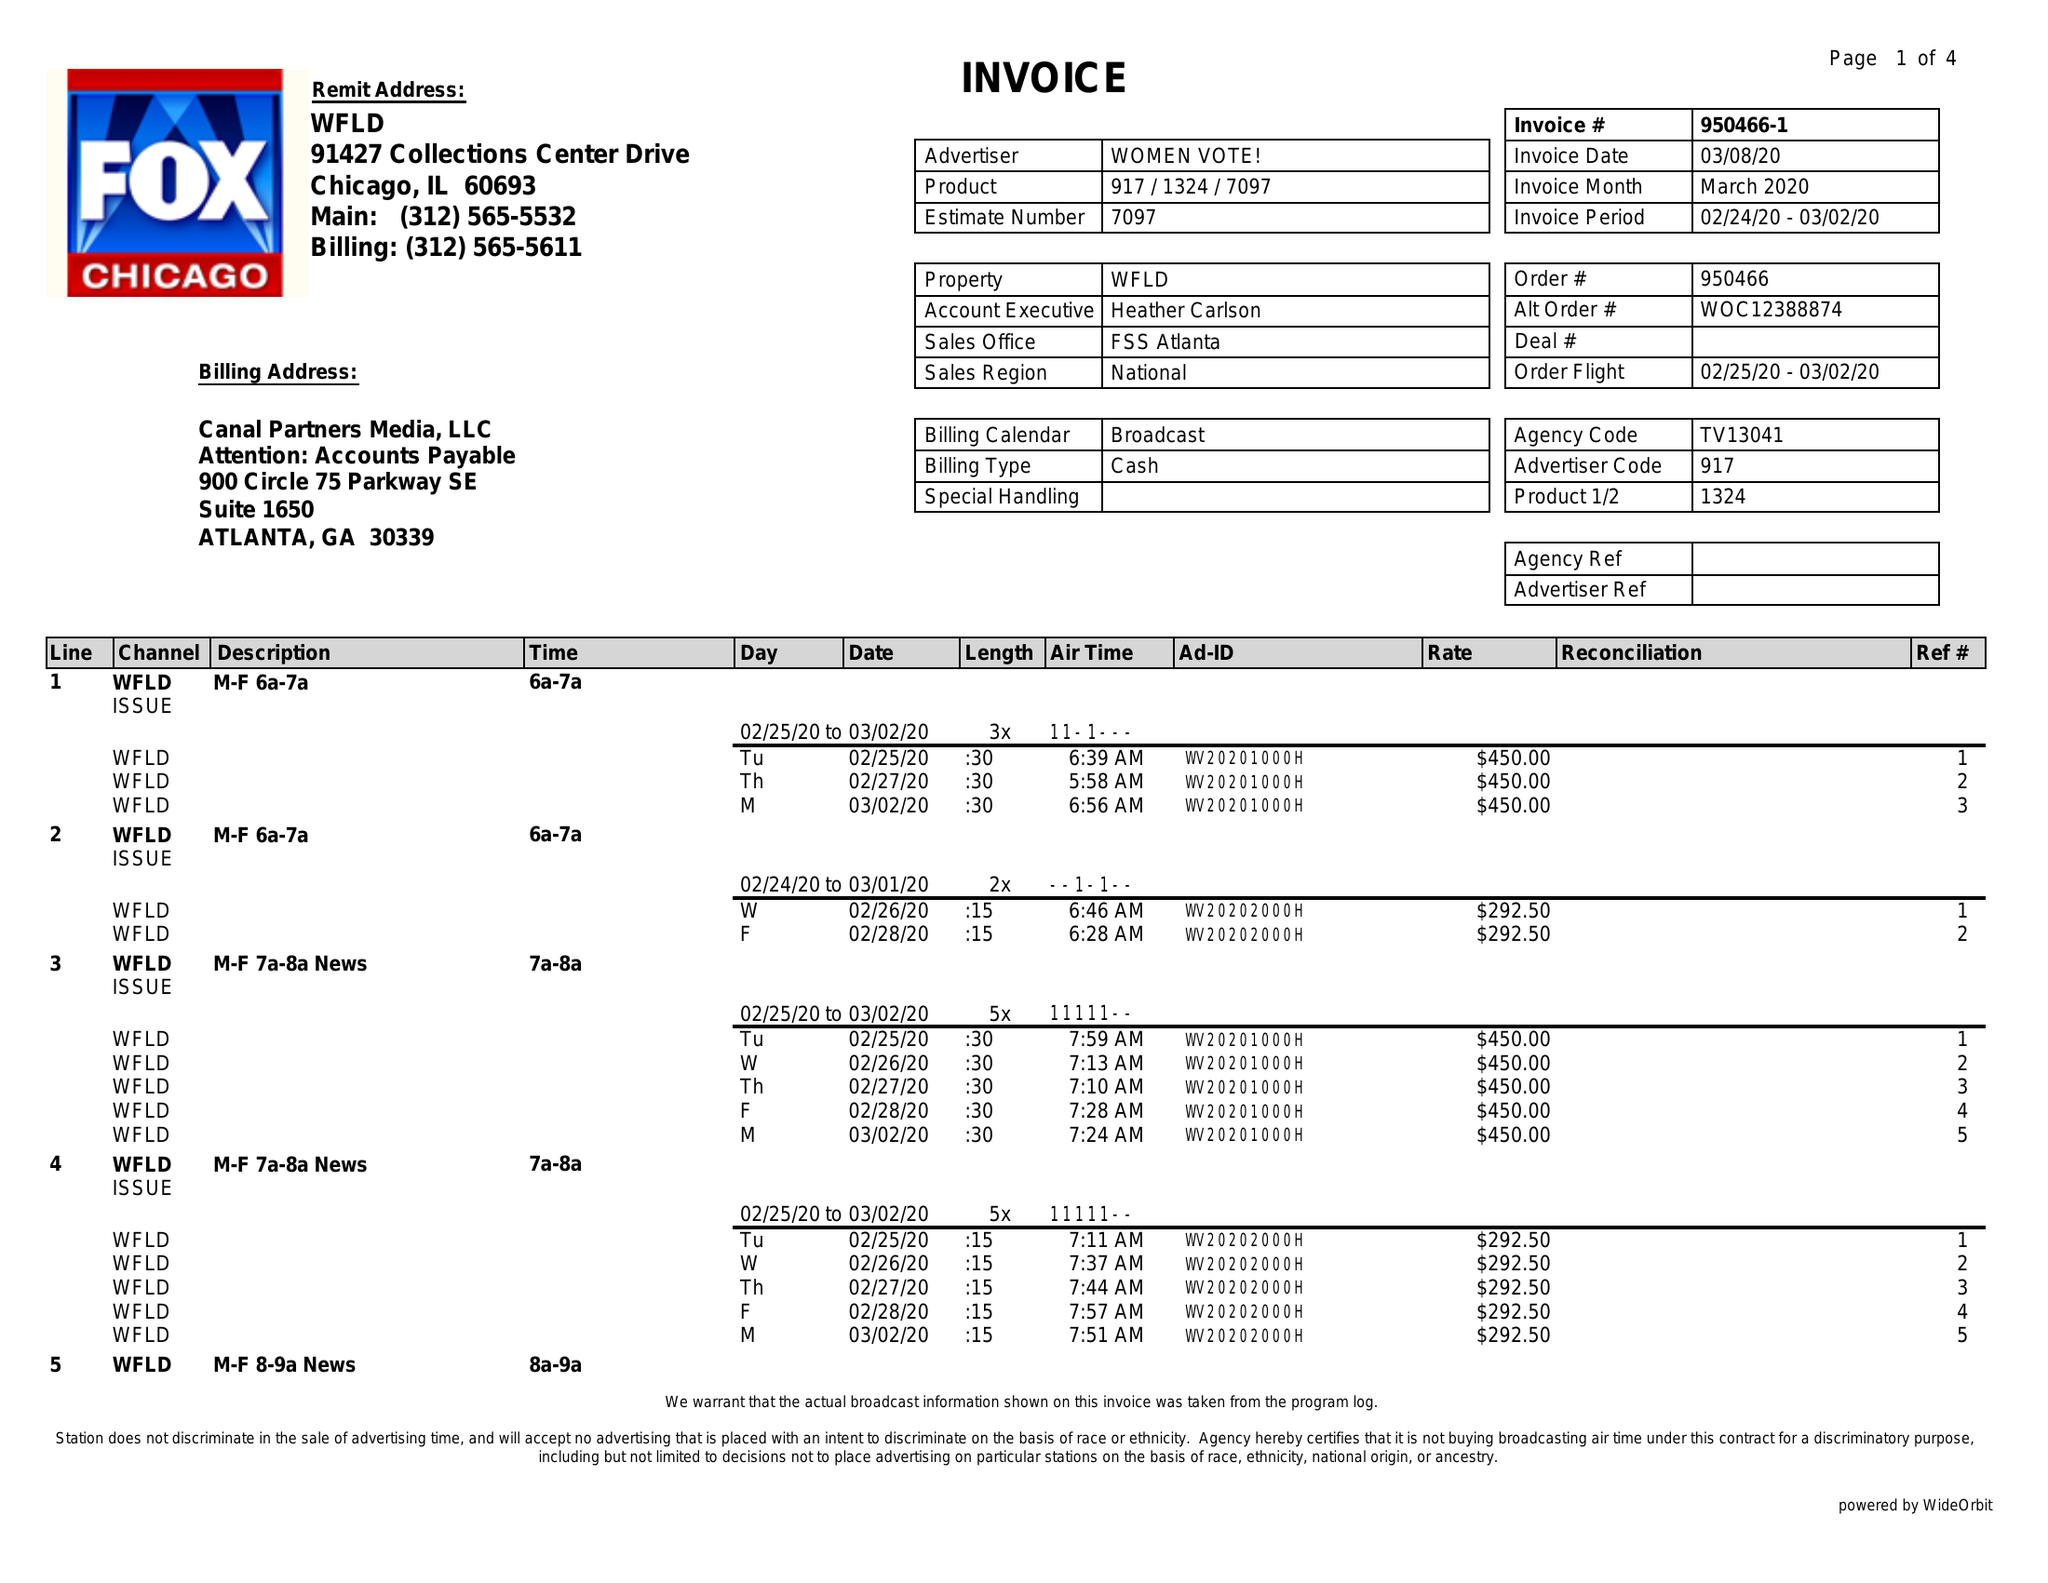What is the value for the flight_from?
Answer the question using a single word or phrase. 02/25/20 